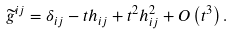Convert formula to latex. <formula><loc_0><loc_0><loc_500><loc_500>\widetilde { g } ^ { i j } = \delta _ { i j } - t h _ { i j } + t ^ { 2 } h _ { i j } ^ { 2 } + O \left ( t ^ { 3 } \right ) .</formula> 